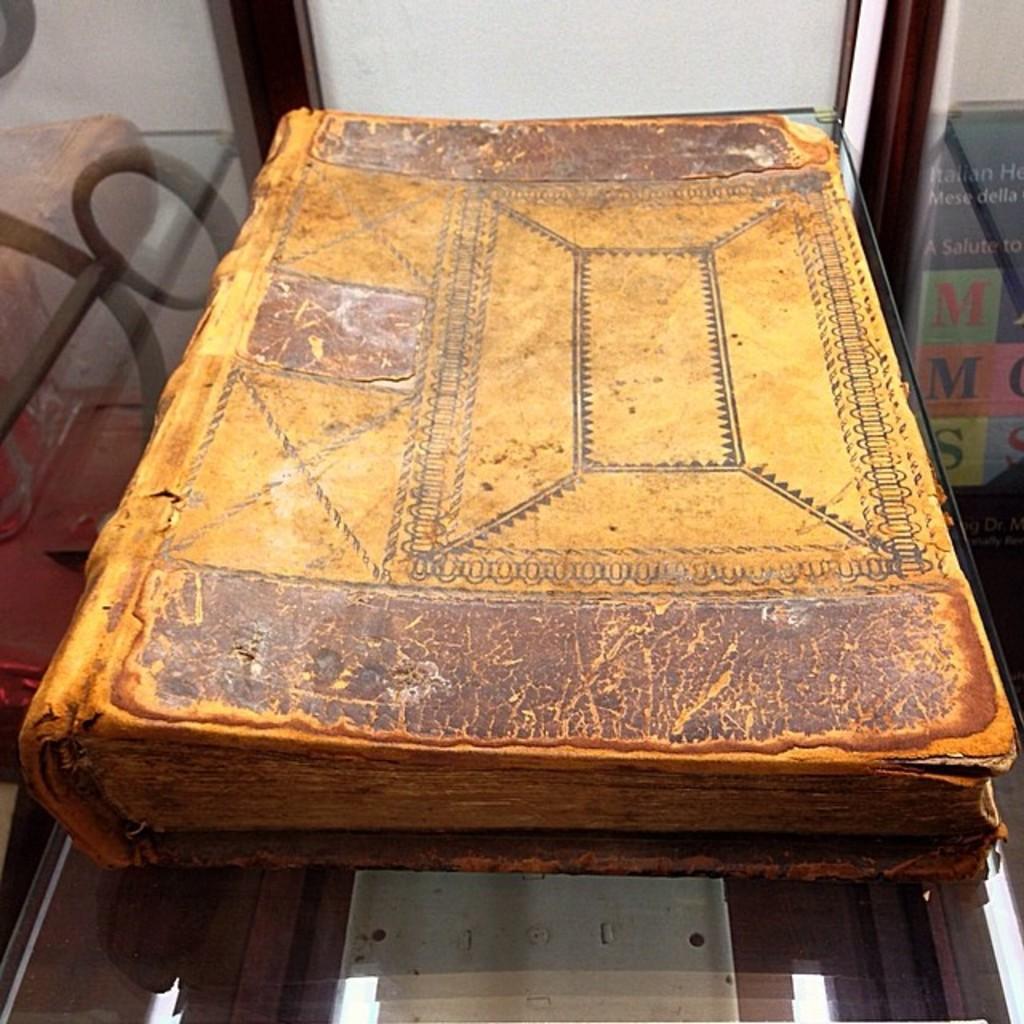Could you give a brief overview of what you see in this image? In this image there is an old book on the glass table. 